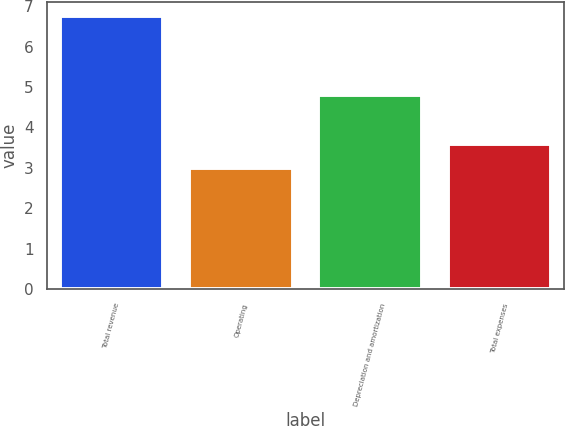Convert chart. <chart><loc_0><loc_0><loc_500><loc_500><bar_chart><fcel>Total revenue<fcel>Operating<fcel>Depreciation and amortization<fcel>Total expenses<nl><fcel>6.76<fcel>3.01<fcel>4.8<fcel>3.6<nl></chart> 